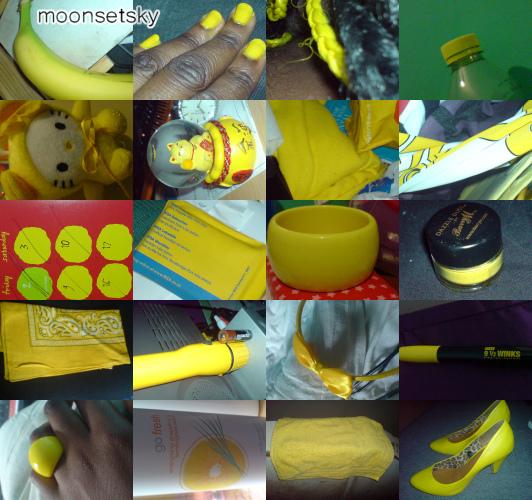How many of the items here have been grown?
Write a very short answer. 1. What is the predominant color in this photo collage?
Concise answer only. Yellow. Are there heels?
Short answer required. Yes. 